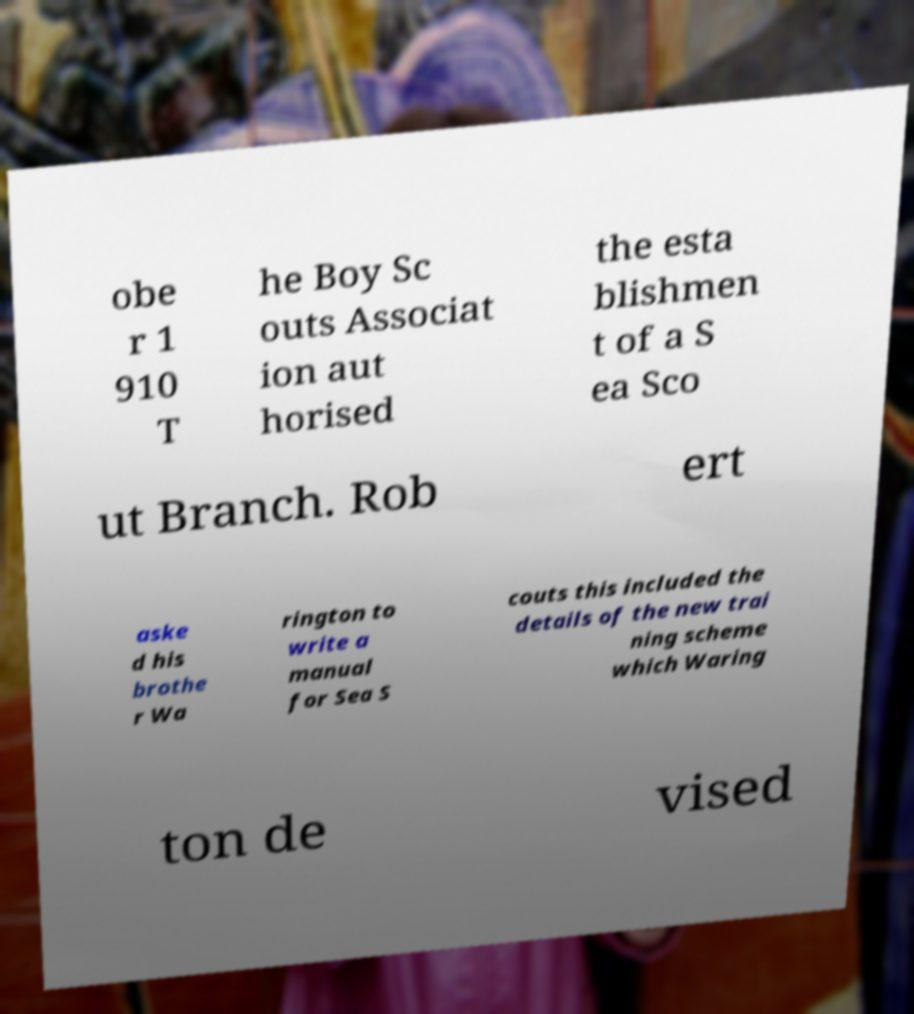Could you extract and type out the text from this image? obe r 1 910 T he Boy Sc outs Associat ion aut horised the esta blishmen t of a S ea Sco ut Branch. Rob ert aske d his brothe r Wa rington to write a manual for Sea S couts this included the details of the new trai ning scheme which Waring ton de vised 